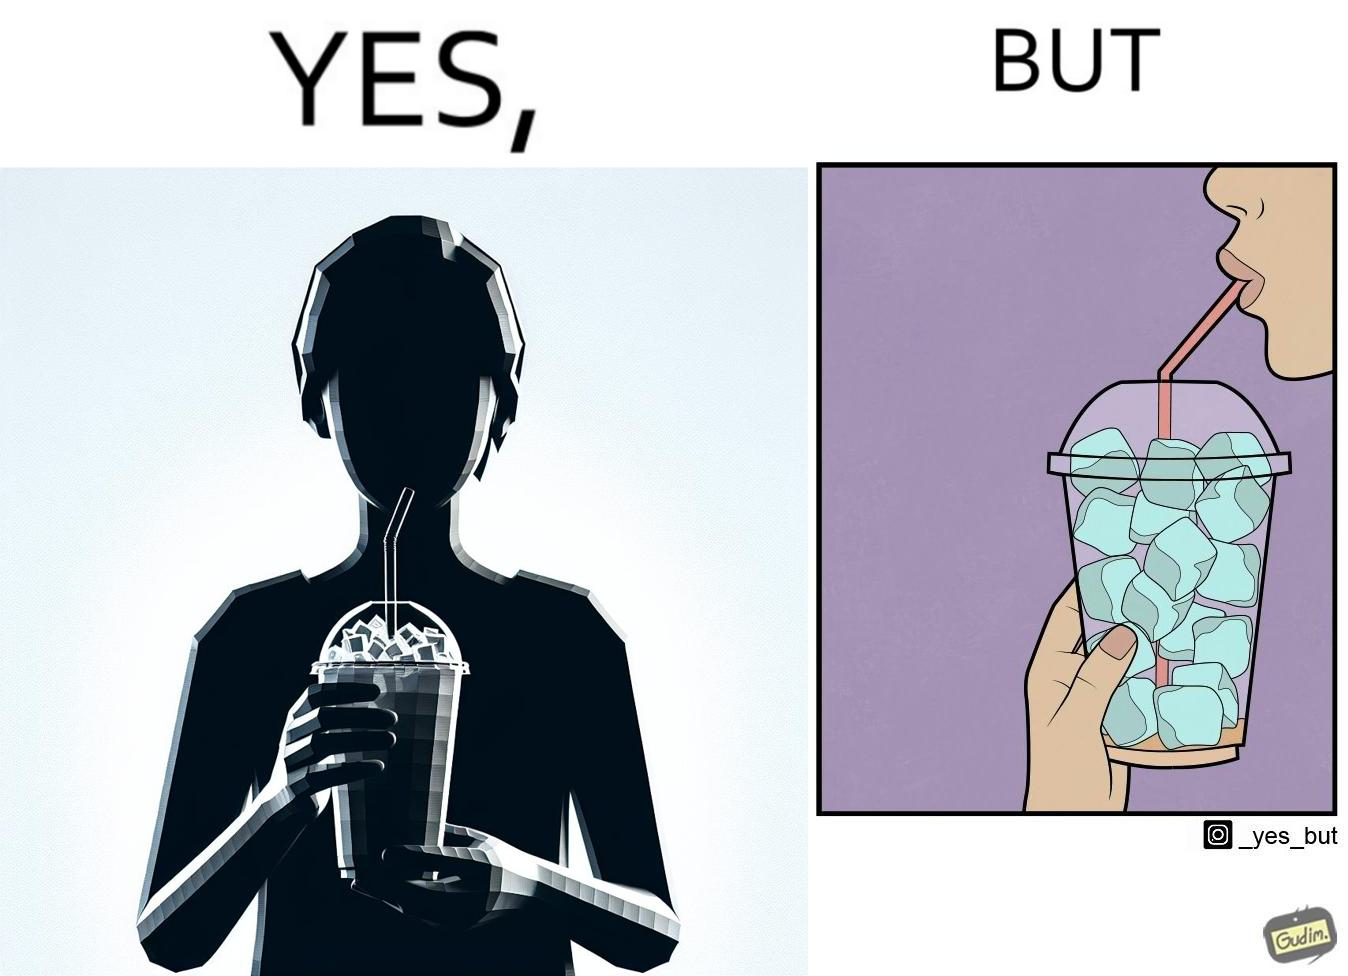Is this image satirical or non-satirical? Yes, this image is satirical. 